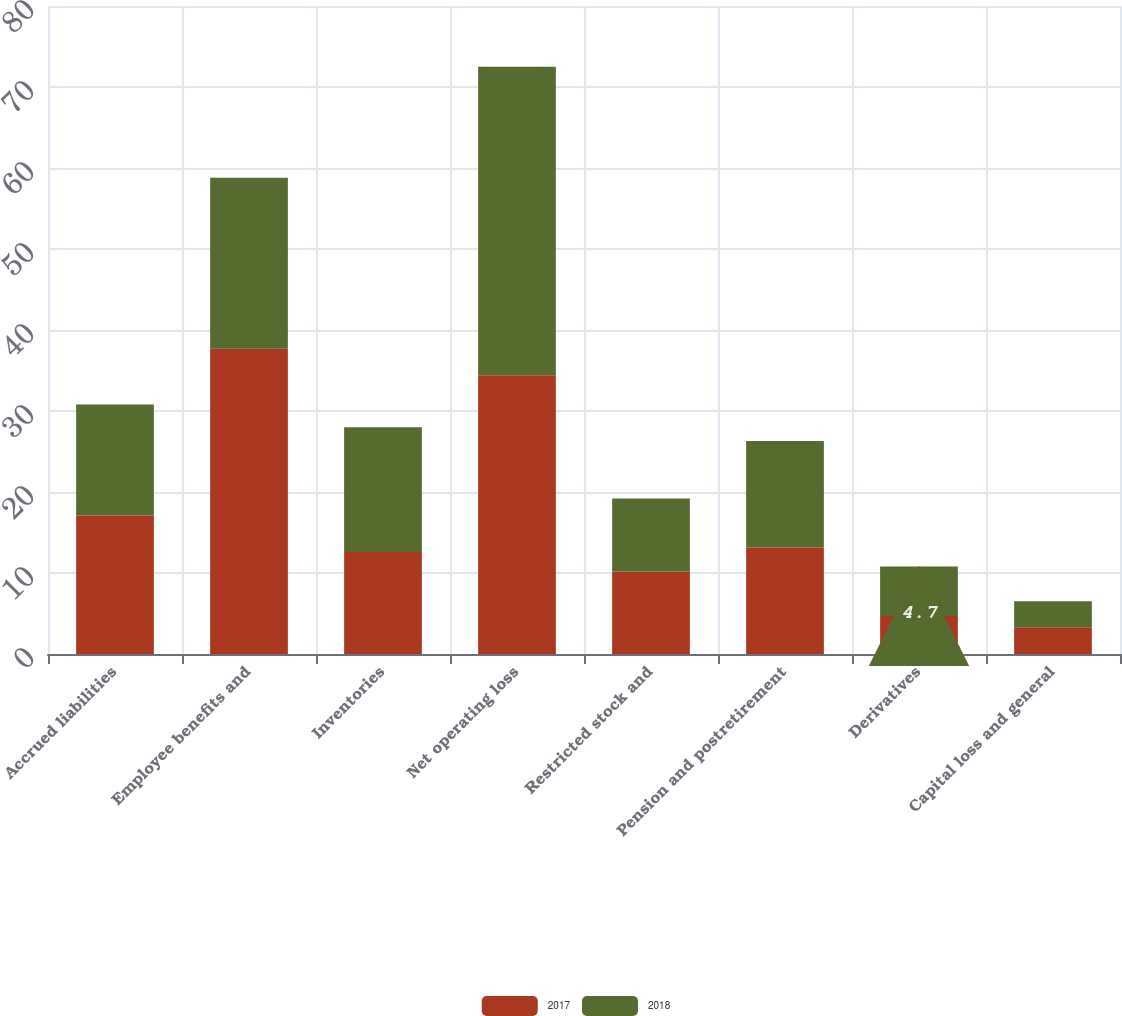Convert chart. <chart><loc_0><loc_0><loc_500><loc_500><stacked_bar_chart><ecel><fcel>Accrued liabilities<fcel>Employee benefits and<fcel>Inventories<fcel>Net operating loss<fcel>Restricted stock and<fcel>Pension and postretirement<fcel>Derivatives<fcel>Capital loss and general<nl><fcel>2017<fcel>17.1<fcel>37.7<fcel>12.6<fcel>34.4<fcel>10.2<fcel>13.15<fcel>4.7<fcel>3.3<nl><fcel>2018<fcel>13.7<fcel>21.1<fcel>15.4<fcel>38.1<fcel>9<fcel>13.15<fcel>6.1<fcel>3.2<nl></chart> 